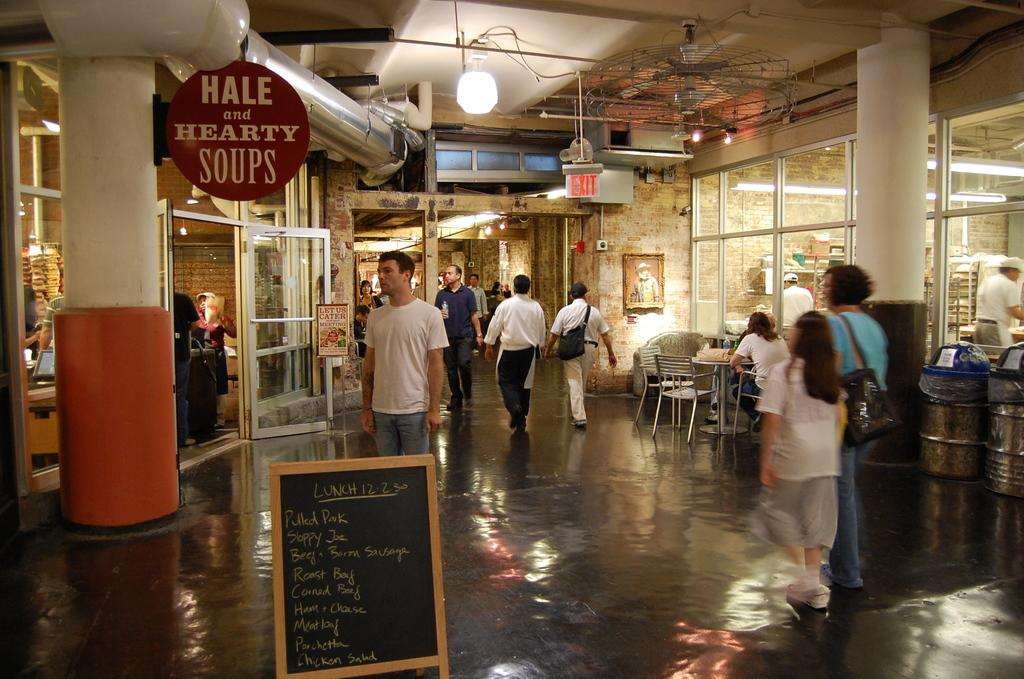What are the persons in the image doing? The persons in the image are on the floor. What type of objects can be seen in the image? There are boards, pillars, chairs, tables, bins, a door, glasses, and lights in the image. What is visible in the background of the image? There is a wall in the background of the image. What type of bushes can be seen growing near the door in the image? There are no bushes visible in the image; only the wall is present in the background. What type of trail can be seen leading up to the door in the image? There is no trail visible in the image; only the door and the wall in the background are present. 